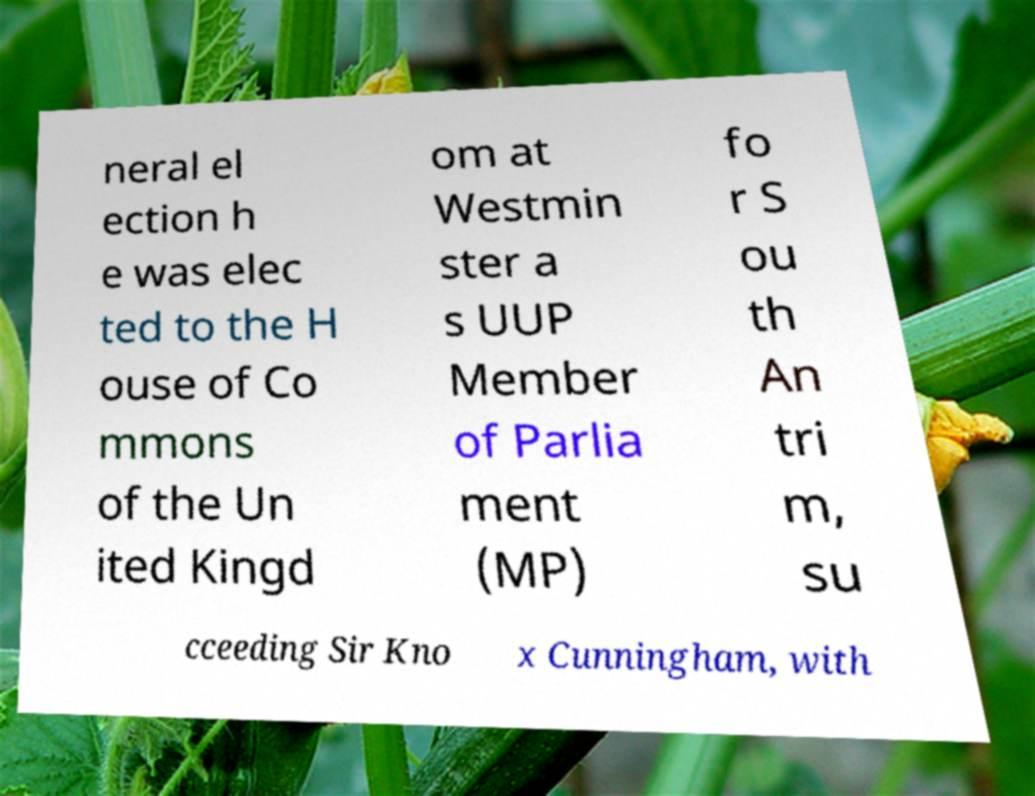Please read and relay the text visible in this image. What does it say? neral el ection h e was elec ted to the H ouse of Co mmons of the Un ited Kingd om at Westmin ster a s UUP Member of Parlia ment (MP) fo r S ou th An tri m, su cceeding Sir Kno x Cunningham, with 